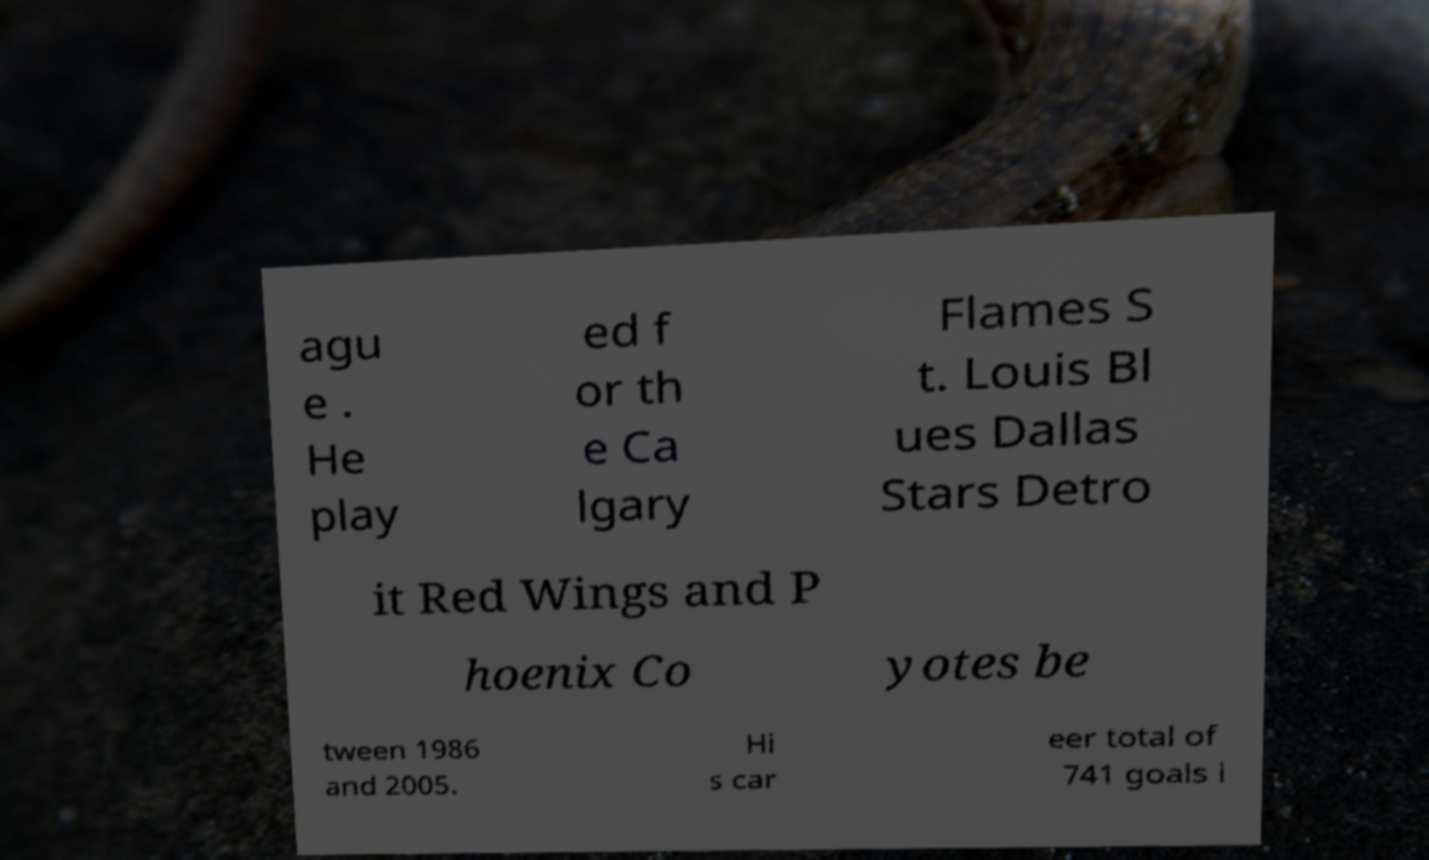Can you accurately transcribe the text from the provided image for me? agu e . He play ed f or th e Ca lgary Flames S t. Louis Bl ues Dallas Stars Detro it Red Wings and P hoenix Co yotes be tween 1986 and 2005. Hi s car eer total of 741 goals i 